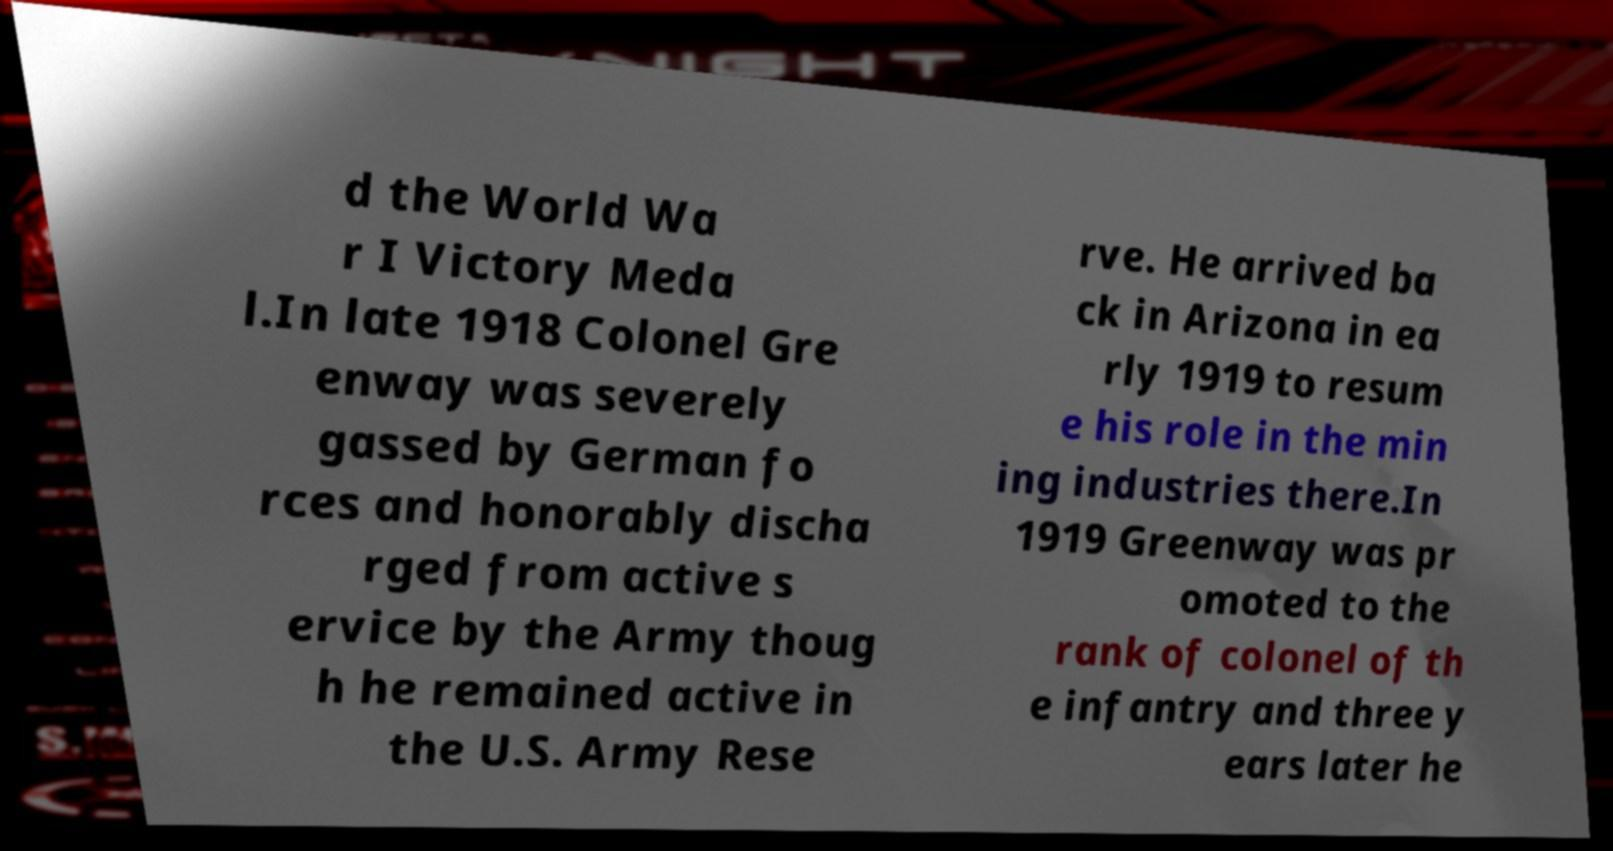I need the written content from this picture converted into text. Can you do that? d the World Wa r I Victory Meda l.In late 1918 Colonel Gre enway was severely gassed by German fo rces and honorably discha rged from active s ervice by the Army thoug h he remained active in the U.S. Army Rese rve. He arrived ba ck in Arizona in ea rly 1919 to resum e his role in the min ing industries there.In 1919 Greenway was pr omoted to the rank of colonel of th e infantry and three y ears later he 